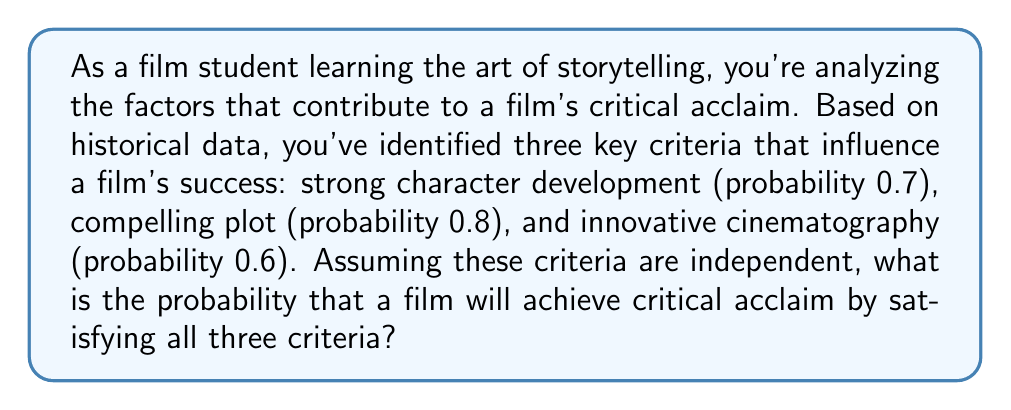Help me with this question. To solve this problem, we need to use the multiplication rule for independent events. Since we're looking for the probability of all three criteria being satisfied simultaneously, and they are independent, we multiply their individual probabilities.

Let's define our events:
A: Strong character development (P(A) = 0.7)
B: Compelling plot (P(B) = 0.8)
C: Innovative cinematography (P(C) = 0.6)

We want to find P(A ∩ B ∩ C), which is the probability of all three events occurring together.

For independent events, P(A ∩ B ∩ C) = P(A) × P(B) × P(C)

Substituting the given probabilities:

$$P(A \cap B \cap C) = 0.7 \times 0.8 \times 0.6$$

Now, let's calculate:

$$P(A \cap B \cap C) = 0.7 \times 0.8 \times 0.6 = 0.336$$

Therefore, the probability of a film achieving critical acclaim by satisfying all three criteria is 0.336 or 33.6%.
Answer: $0.336$ or $33.6\%$ 